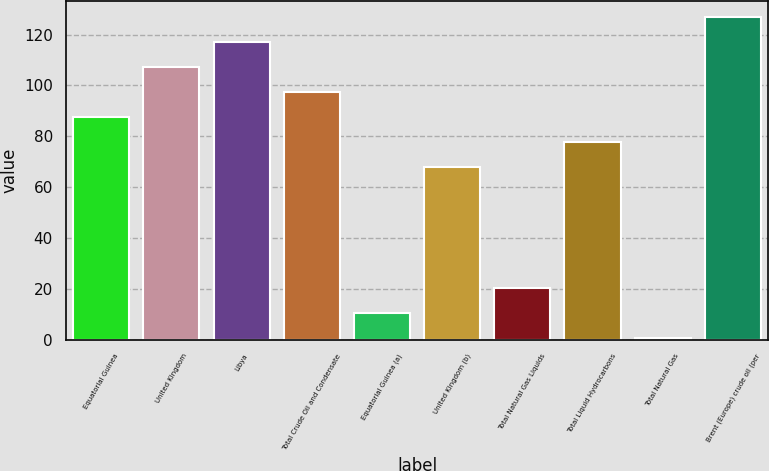<chart> <loc_0><loc_0><loc_500><loc_500><bar_chart><fcel>Equatorial Guinea<fcel>United Kingdom<fcel>Libya<fcel>Total Crude Oil and Condensate<fcel>Equatorial Guinea (a)<fcel>United Kingdom (b)<fcel>Total Natural Gas Liquids<fcel>Total Liquid Hydrocarbons<fcel>Total Natural Gas<fcel>Brent (Europe) crude oil (per<nl><fcel>87.39<fcel>107.05<fcel>116.88<fcel>97.22<fcel>10.55<fcel>67.73<fcel>20.38<fcel>77.56<fcel>0.72<fcel>126.71<nl></chart> 